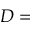<formula> <loc_0><loc_0><loc_500><loc_500>D =</formula> 